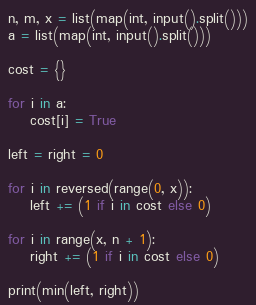<code> <loc_0><loc_0><loc_500><loc_500><_Python_>n, m, x = list(map(int, input().split()))
a = list(map(int, input().split()))

cost = {}

for i in a:
    cost[i] = True

left = right = 0

for i in reversed(range(0, x)):
    left += (1 if i in cost else 0)

for i in range(x, n + 1):
    right += (1 if i in cost else 0)

print(min(left, right))
</code> 